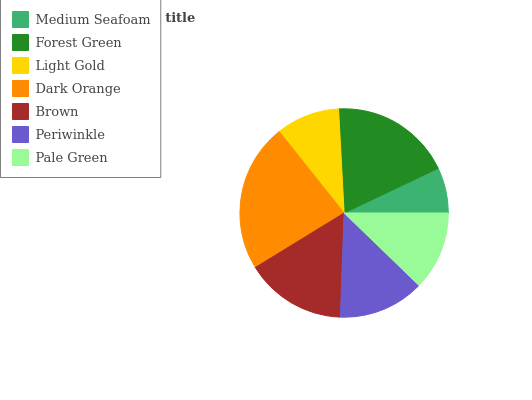Is Medium Seafoam the minimum?
Answer yes or no. Yes. Is Dark Orange the maximum?
Answer yes or no. Yes. Is Forest Green the minimum?
Answer yes or no. No. Is Forest Green the maximum?
Answer yes or no. No. Is Forest Green greater than Medium Seafoam?
Answer yes or no. Yes. Is Medium Seafoam less than Forest Green?
Answer yes or no. Yes. Is Medium Seafoam greater than Forest Green?
Answer yes or no. No. Is Forest Green less than Medium Seafoam?
Answer yes or no. No. Is Periwinkle the high median?
Answer yes or no. Yes. Is Periwinkle the low median?
Answer yes or no. Yes. Is Forest Green the high median?
Answer yes or no. No. Is Medium Seafoam the low median?
Answer yes or no. No. 